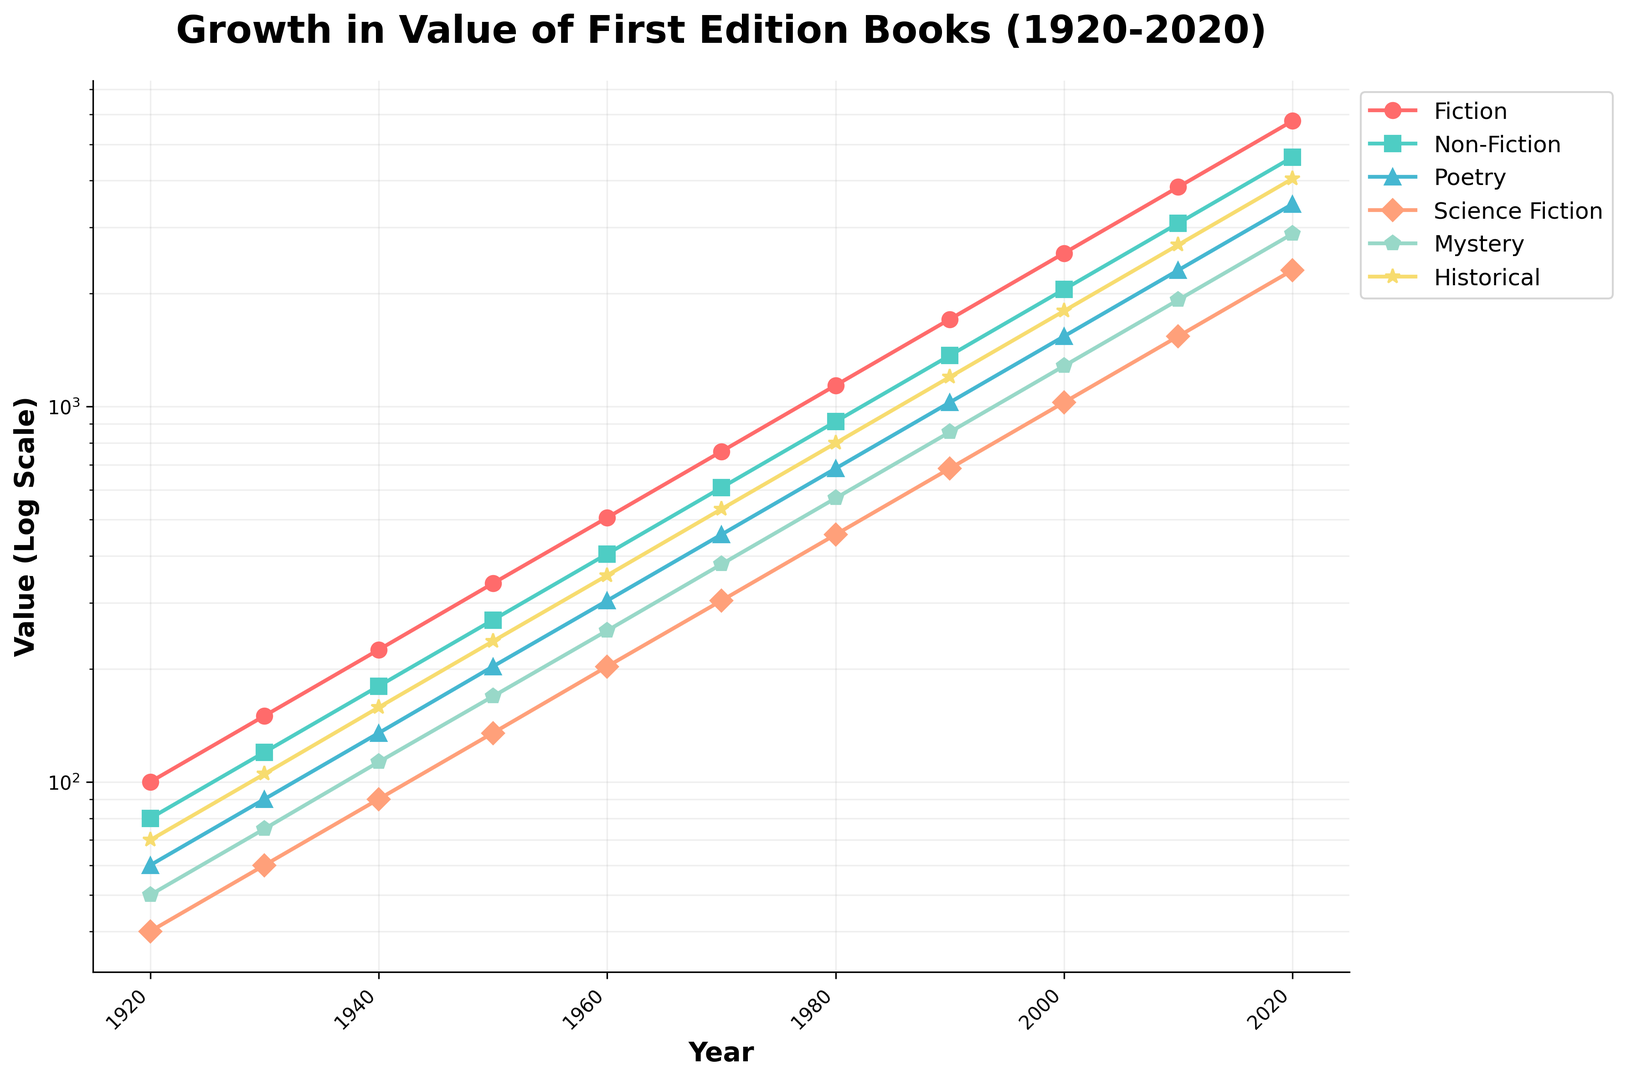Which genre had the highest value in 2020? Look at the y-values for the year 2020 and compare across genres. Fiction has the highest value at 5767.
Answer: Fiction By how much did the value of Science Fiction books increase from 1920 to 2020? Subtract the value in 1920 from the value in 2020 for Science Fiction. 2309 - 40 = 2269.
Answer: 2269 Which genre had the lowest growth rate from 1920 to 2020? Compare the growth by calculating the ratio of the 2020 value to the 1920 value for each genre. Poetry grew by a factor of 3463 / 60 ≈ 57.717, which is the smallest growth factor among all genres.
Answer: Poetry What is the average value of Non-Fiction books in 1960 and 1970? The values are 405 in 1960 and 608 in 1970. Average = (405 + 608) / 2 = 1013 / 2 = 506.5.
Answer: 506.5 In which decade did the value of Mystery books first surpass 1000? Identify the value for Mystery in each decade and find the earliest one where it exceeds 1000. This happens in the 2000s (1283).
Answer: 2000s Which genre shows the steepest increase in value between 2000 and 2010? Compare the slopes between 2000 and 2010 for each genre by calculating the differences. Poetry increases from 1539 to 2309 (2309 - 1539 = 770), which is the steepest.
Answer: Poetry Calculate the cumulative value of all genres in 1940. Sum up the values for all genres in 1940: 225 + 180 + 135 + 90 + 113 + 158 = 901.
Answer: 901 Which genre had a higher value in 1950: Historical or Mystery? Compare the y-values for Historical (237) and Mystery (169) in 1950.
Answer: Historical What is the ratio of the value of Fiction to Science Fiction in 2020? Calculate the ratio: Fiction (5767) and Science Fiction (2309). Ratio = 5767 / 2309 ≈ 2.50.
Answer: 2.50 